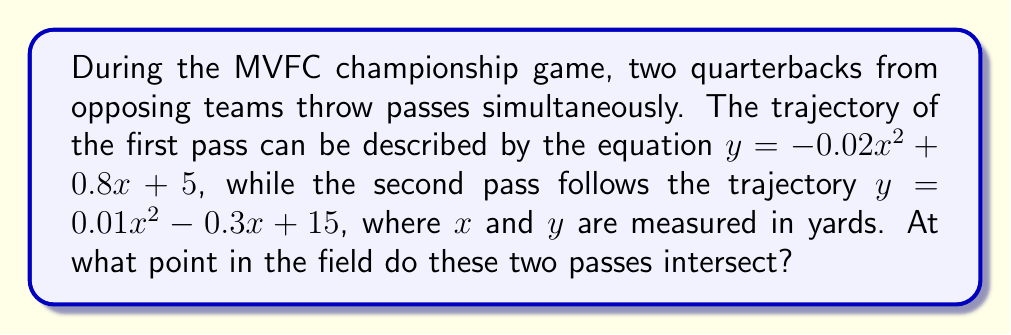Teach me how to tackle this problem. To find the intersection point of the two pass trajectories, we need to solve the system of equations:

$$\begin{cases}
y = -0.02x^2 + 0.8x + 5 \\
y = 0.01x^2 - 0.3x + 15
\end{cases}$$

Step 1: Set the equations equal to each other
$-0.02x^2 + 0.8x + 5 = 0.01x^2 - 0.3x + 15$

Step 2: Rearrange the equation to standard form
$-0.03x^2 + 1.1x - 10 = 0$

Step 3: Solve the quadratic equation using the quadratic formula
$x = \frac{-b \pm \sqrt{b^2 - 4ac}}{2a}$

Where $a = -0.03$, $b = 1.1$, and $c = -10$

$x = \frac{-1.1 \pm \sqrt{1.1^2 - 4(-0.03)(-10)}}{2(-0.03)}$

$x = \frac{-1.1 \pm \sqrt{1.21 - 1.2}}{-0.06}$

$x = \frac{-1.1 \pm \sqrt{0.01}}{-0.06}$

$x = \frac{-1.1 \pm 0.1}{-0.06}$

This gives us two solutions:
$x_1 = \frac{-1.1 + 0.1}{-0.06} = \frac{-1}{-0.06} \approx 16.67$ yards
$x_2 = \frac{-1.1 - 0.1}{-0.06} = \frac{-1.2}{-0.06} = 20$ yards

Step 4: Calculate the y-coordinate using either of the original equations
For $x = 20$:
$y = -0.02(20)^2 + 0.8(20) + 5 = -8 + 16 + 5 = 13$ yards

Therefore, the intersection point is at (20, 13) yards on the field.
Answer: (20, 13) yards 